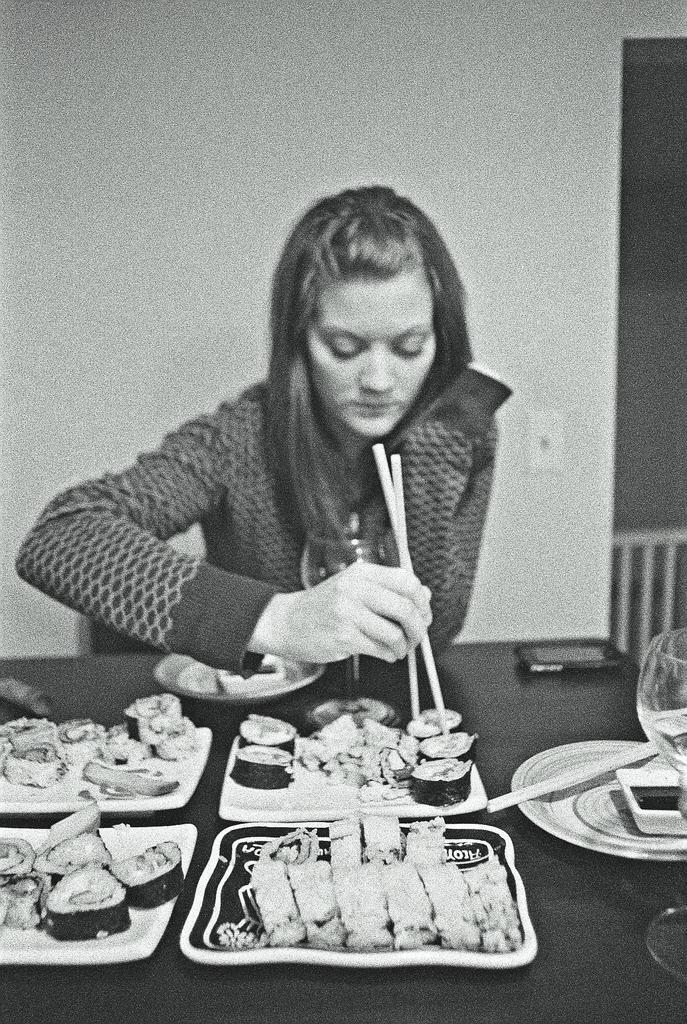Describe this image in one or two sentences. This is a black and white image. There is a table and a girl. she is sitting on chair. On the table there is a plate, chopsticks, eatables, mobile phone, glass. She is eating with chopsticks. 